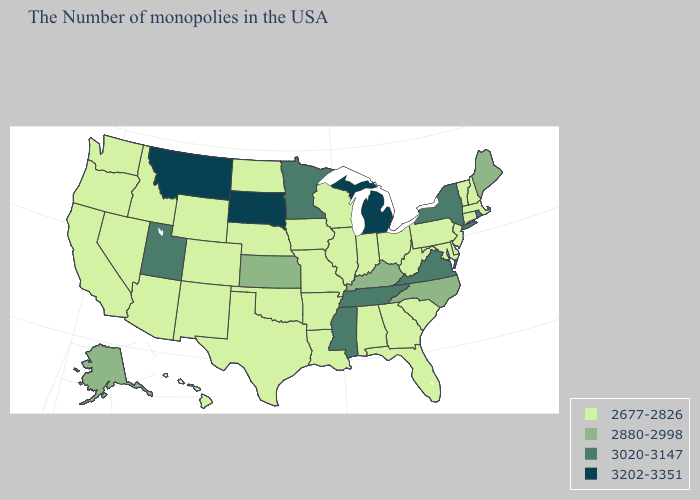Does South Dakota have the highest value in the USA?
Give a very brief answer. Yes. Among the states that border Oklahoma , which have the highest value?
Be succinct. Kansas. Which states have the highest value in the USA?
Short answer required. Michigan, South Dakota, Montana. What is the lowest value in states that border Utah?
Write a very short answer. 2677-2826. What is the value of Missouri?
Keep it brief. 2677-2826. Name the states that have a value in the range 2677-2826?
Keep it brief. Massachusetts, New Hampshire, Vermont, Connecticut, New Jersey, Delaware, Maryland, Pennsylvania, South Carolina, West Virginia, Ohio, Florida, Georgia, Indiana, Alabama, Wisconsin, Illinois, Louisiana, Missouri, Arkansas, Iowa, Nebraska, Oklahoma, Texas, North Dakota, Wyoming, Colorado, New Mexico, Arizona, Idaho, Nevada, California, Washington, Oregon, Hawaii. Name the states that have a value in the range 2677-2826?
Short answer required. Massachusetts, New Hampshire, Vermont, Connecticut, New Jersey, Delaware, Maryland, Pennsylvania, South Carolina, West Virginia, Ohio, Florida, Georgia, Indiana, Alabama, Wisconsin, Illinois, Louisiana, Missouri, Arkansas, Iowa, Nebraska, Oklahoma, Texas, North Dakota, Wyoming, Colorado, New Mexico, Arizona, Idaho, Nevada, California, Washington, Oregon, Hawaii. What is the value of Minnesota?
Answer briefly. 3020-3147. Name the states that have a value in the range 3202-3351?
Give a very brief answer. Michigan, South Dakota, Montana. What is the lowest value in states that border South Carolina?
Give a very brief answer. 2677-2826. Name the states that have a value in the range 3202-3351?
Concise answer only. Michigan, South Dakota, Montana. Name the states that have a value in the range 3020-3147?
Quick response, please. Rhode Island, New York, Virginia, Tennessee, Mississippi, Minnesota, Utah. What is the highest value in the West ?
Be succinct. 3202-3351. What is the lowest value in the MidWest?
Keep it brief. 2677-2826. Name the states that have a value in the range 3020-3147?
Be succinct. Rhode Island, New York, Virginia, Tennessee, Mississippi, Minnesota, Utah. 